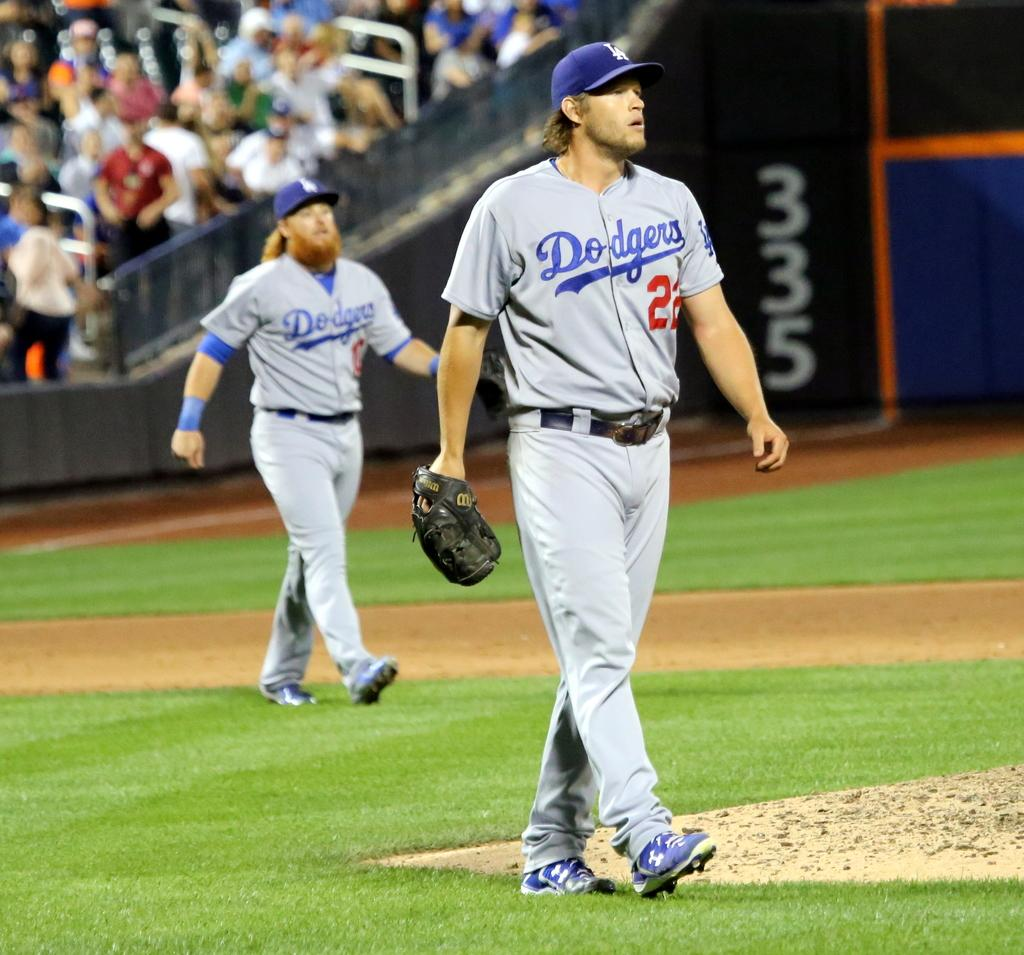<image>
Share a concise interpretation of the image provided. Two male baseball players for the Dodgers on the field. 